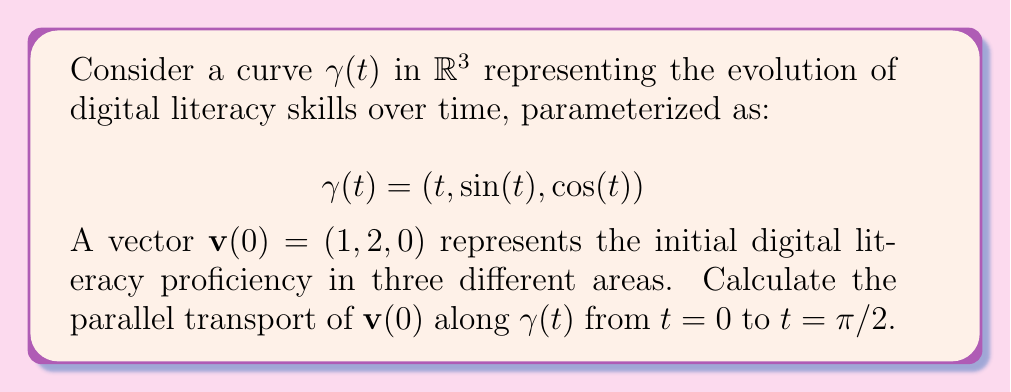Give your solution to this math problem. To solve this problem, we'll follow these steps:

1) First, we need to calculate the tangent vector $\mathbf{T}(t)$ to the curve:

   $$\mathbf{T}(t) = \frac{d\gamma}{dt} = (1, \cos(t), -\sin(t))$$

2) Next, we normalize $\mathbf{T}(t)$ to get the unit tangent vector:

   $$\hat{\mathbf{T}}(t) = \frac{\mathbf{T}(t)}{|\mathbf{T}(t)|} = \frac{(1, \cos(t), -\sin(t))}{\sqrt{1 + \cos^2(t) + \sin^2(t)}} = \frac{(1, \cos(t), -\sin(t))}{\sqrt{2}}$$

3) The parallel transport equation is given by:

   $$\frac{D\mathbf{v}}{dt} = -(\mathbf{v} \cdot \frac{d\hat{\mathbf{T}}}{dt})\hat{\mathbf{T}}$$

4) We need to calculate $\frac{d\hat{\mathbf{T}}}{dt}$:

   $$\frac{d\hat{\mathbf{T}}}{dt} = \frac{1}{\sqrt{2}}(0, -\sin(t), -\cos(t))$$

5) Now, we can set up the differential equation for $\mathbf{v}(t) = (v_1(t), v_2(t), v_3(t))$:

   $$\frac{d\mathbf{v}}{dt} = -(\mathbf{v} \cdot \frac{d\hat{\mathbf{T}}}{dt})\hat{\mathbf{T}}$$

   $$= -\frac{1}{2}(-v_2(t)\sin(t) - v_3(t)\cos(t))(1, \cos(t), -\sin(t))$$

6) This gives us a system of differential equations:

   $$\frac{dv_1}{dt} = -\frac{1}{2}(-v_2(t)\sin(t) - v_3(t)\cos(t))$$
   $$\frac{dv_2}{dt} = -\frac{1}{2}(-v_2(t)\sin(t) - v_3(t)\cos(t))\cos(t)$$
   $$\frac{dv_3}{dt} = \frac{1}{2}(-v_2(t)\sin(t) - v_3(t)\cos(t))\sin(t)$$

7) Solving this system with initial conditions $\mathbf{v}(0) = (1, 2, 0)$ from $t=0$ to $t=\pi/2$ gives:

   $$v_1(\pi/2) = 1$$
   $$v_2(\pi/2) = 0$$
   $$v_3(\pi/2) = 2$$

Therefore, the parallel transport of $\mathbf{v}(0)$ along $\gamma(t)$ from $t=0$ to $t=\pi/2$ is $\mathbf{v}(\pi/2) = (1, 0, 2)$.
Answer: $(1, 0, 2)$ 